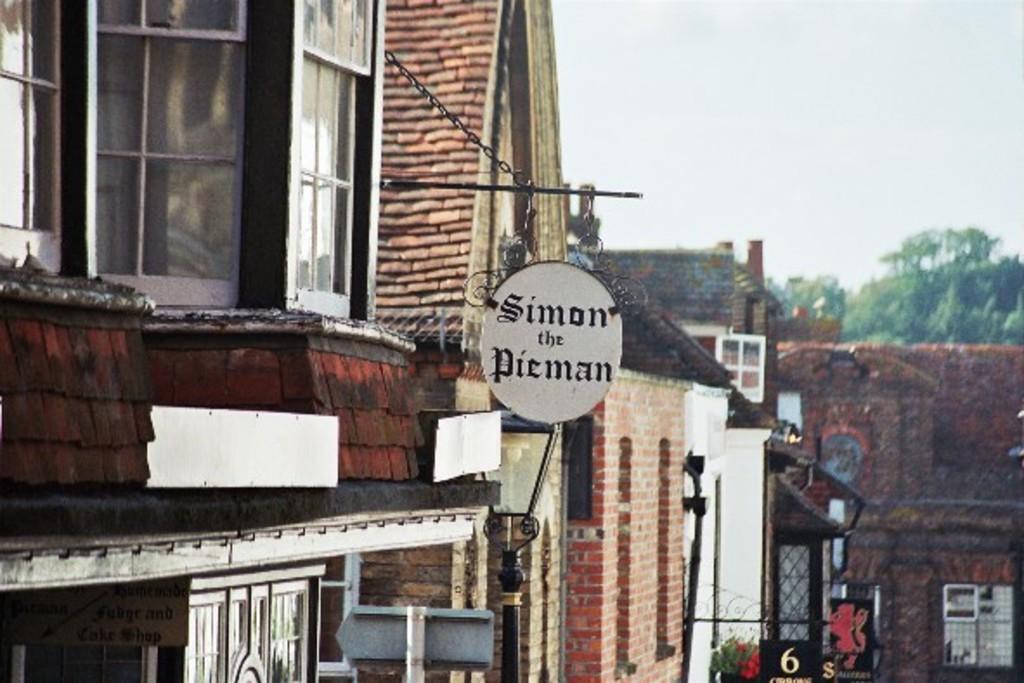Could you give a brief overview of what you see in this image? In the middle of the picture, we see a board in white color with text written as "Simon the pieman". Beside that, we see a building which is made up of brown colored bricks and it has windows. In the background, we see buildings which are made up of bricks. We even see the windows and the railing. We see a flower pot. There are trees in the background. In the right top, we see the sky. 